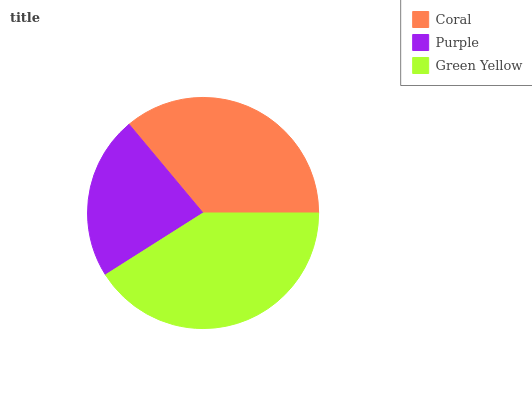Is Purple the minimum?
Answer yes or no. Yes. Is Green Yellow the maximum?
Answer yes or no. Yes. Is Green Yellow the minimum?
Answer yes or no. No. Is Purple the maximum?
Answer yes or no. No. Is Green Yellow greater than Purple?
Answer yes or no. Yes. Is Purple less than Green Yellow?
Answer yes or no. Yes. Is Purple greater than Green Yellow?
Answer yes or no. No. Is Green Yellow less than Purple?
Answer yes or no. No. Is Coral the high median?
Answer yes or no. Yes. Is Coral the low median?
Answer yes or no. Yes. Is Green Yellow the high median?
Answer yes or no. No. Is Green Yellow the low median?
Answer yes or no. No. 